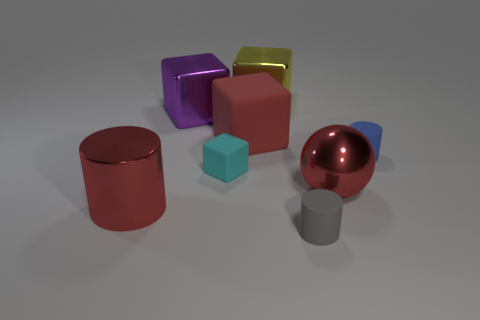There is a purple metal thing; is its shape the same as the matte thing that is to the left of the big red cube?
Offer a terse response. Yes. How many other things are there of the same shape as the cyan object?
Give a very brief answer. 3. What number of objects are either gray matte cylinders or blue objects?
Give a very brief answer. 2. Is the color of the big shiny cylinder the same as the big matte thing?
Provide a succinct answer. Yes. Is there anything else that is the same size as the red rubber cube?
Give a very brief answer. Yes. What shape is the red thing that is behind the cyan object in front of the yellow metallic block?
Make the answer very short. Cube. Is the number of big brown rubber balls less than the number of yellow metal blocks?
Provide a succinct answer. Yes. There is a cylinder that is both on the right side of the large cylinder and to the left of the blue cylinder; how big is it?
Keep it short and to the point. Small. Do the cyan matte object and the red metal cylinder have the same size?
Keep it short and to the point. No. There is a block in front of the big red rubber thing; is its color the same as the big metallic sphere?
Give a very brief answer. No. 